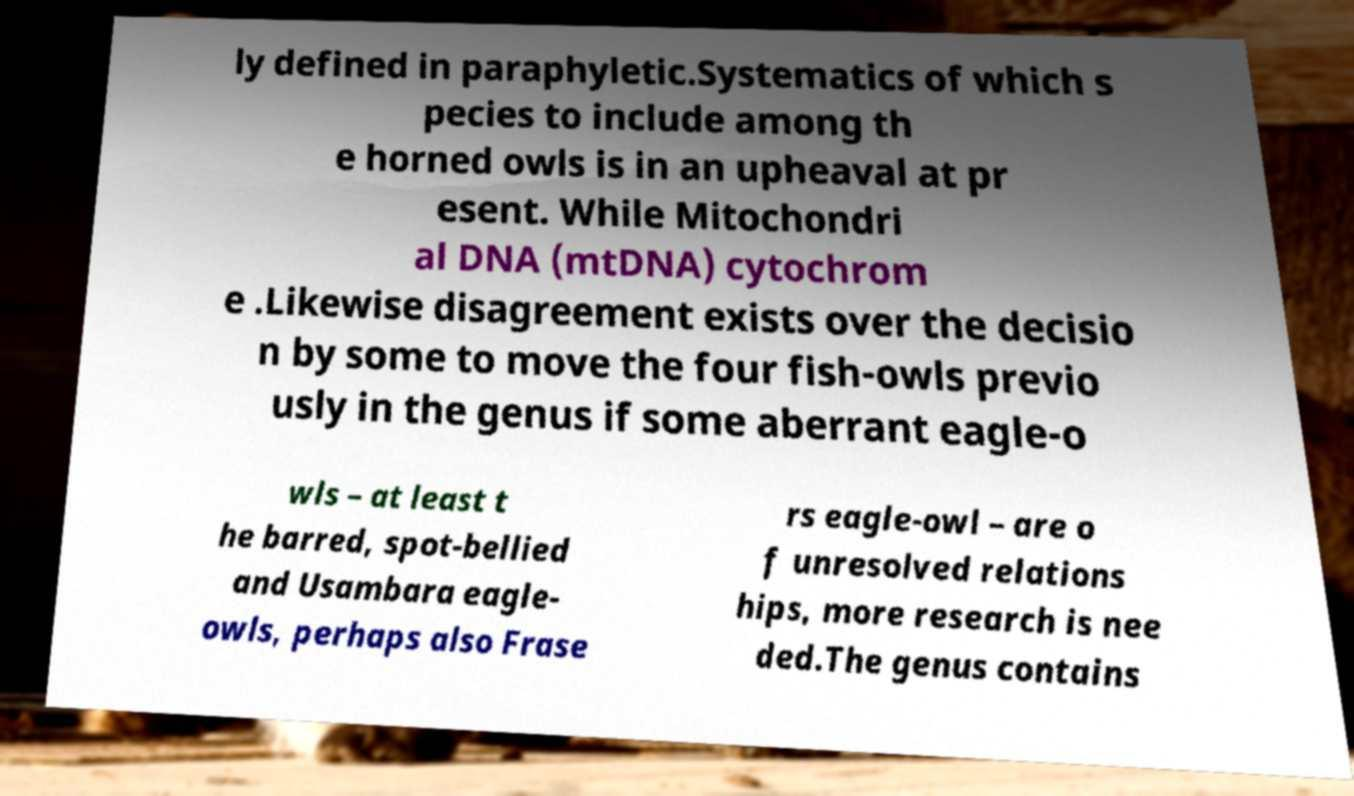What messages or text are displayed in this image? I need them in a readable, typed format. ly defined in paraphyletic.Systematics of which s pecies to include among th e horned owls is in an upheaval at pr esent. While Mitochondri al DNA (mtDNA) cytochrom e .Likewise disagreement exists over the decisio n by some to move the four fish-owls previo usly in the genus if some aberrant eagle-o wls – at least t he barred, spot-bellied and Usambara eagle- owls, perhaps also Frase rs eagle-owl – are o f unresolved relations hips, more research is nee ded.The genus contains 